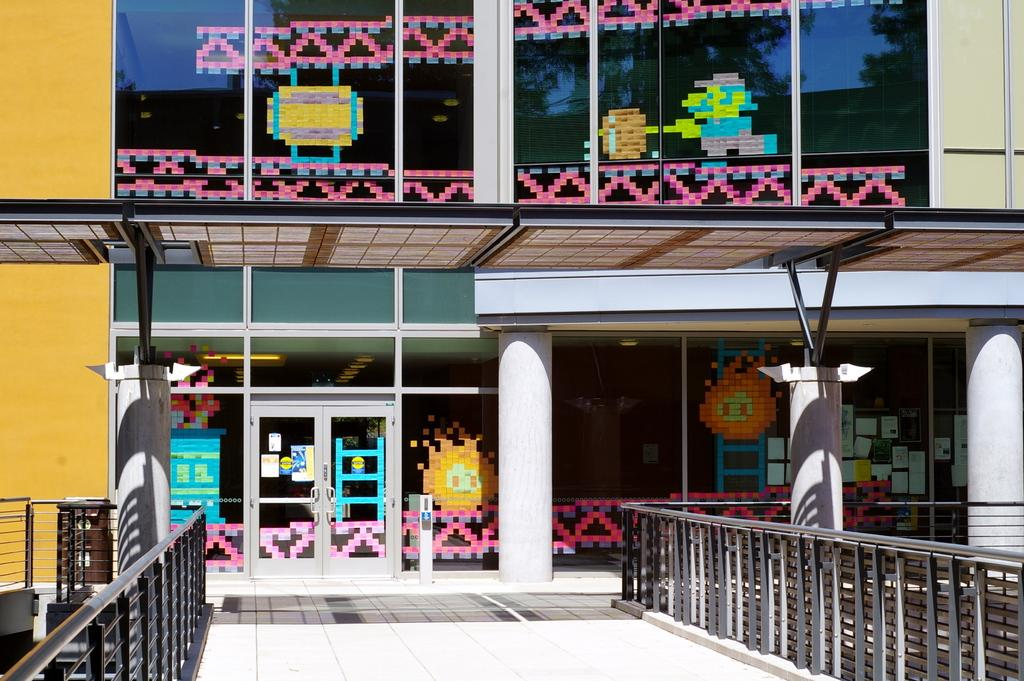What type of structure is visible in the image? There is a building in the image. What surrounds the building on both sides? There are boundaries on both sides of the building. Is there any path or walkway visible in the image? Yes, there is a path in the image. What can be seen on the wall of the building? Colorful designs are present on the wall of the building. What type of meal is being served in the building in the image? There is no indication of a meal being served in the building in the image. 